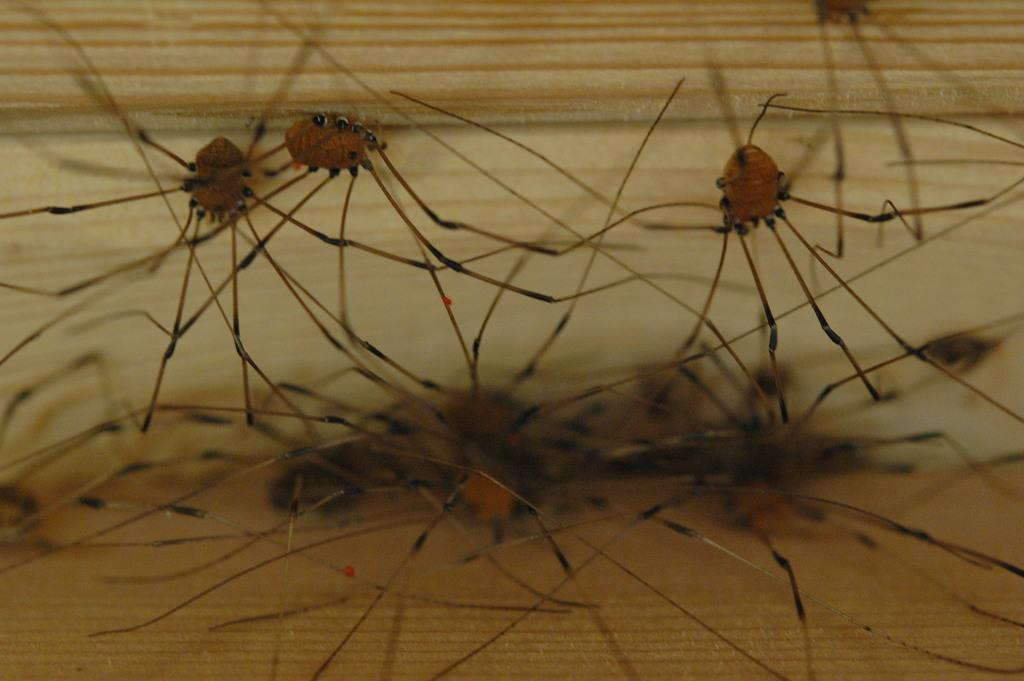What type of living organisms can be seen in the image? Insects can be seen in the image. What type of oil is being used by the insects in the image? There is no oil present in the image, as it features insects. What type of joke is being told by the insects in the image? There is no joke being told in the image, as it features insects. 